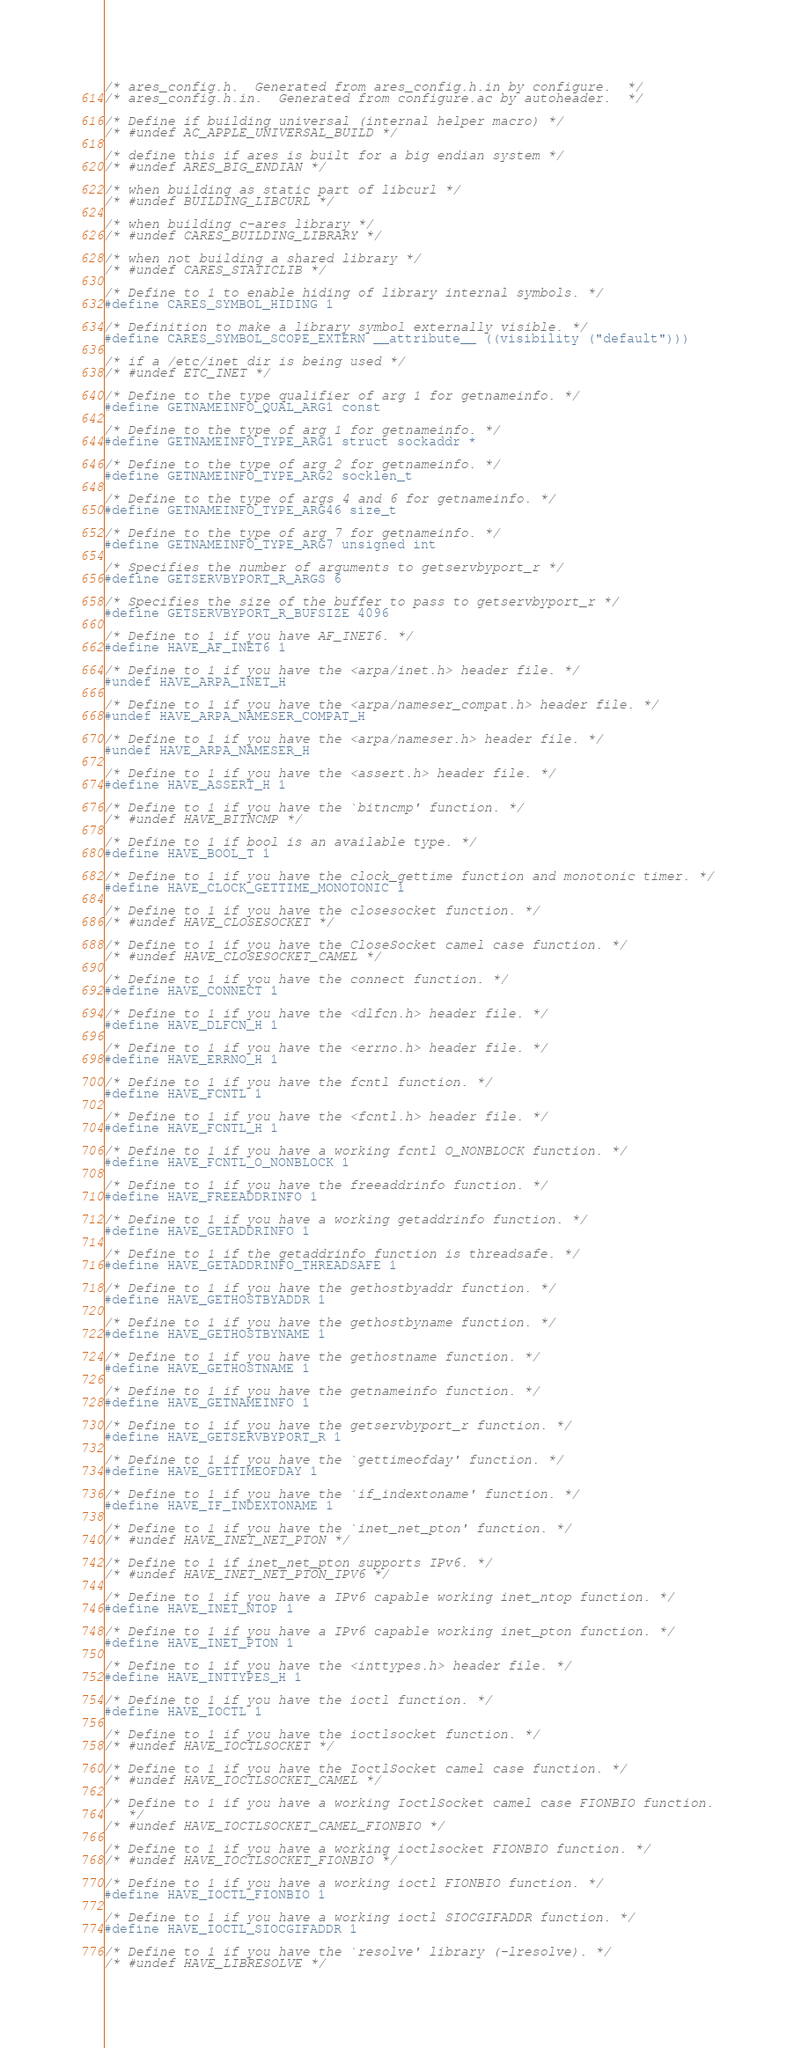<code> <loc_0><loc_0><loc_500><loc_500><_C_>/* ares_config.h.  Generated from ares_config.h.in by configure.  */
/* ares_config.h.in.  Generated from configure.ac by autoheader.  */

/* Define if building universal (internal helper macro) */
/* #undef AC_APPLE_UNIVERSAL_BUILD */

/* define this if ares is built for a big endian system */
/* #undef ARES_BIG_ENDIAN */

/* when building as static part of libcurl */
/* #undef BUILDING_LIBCURL */

/* when building c-ares library */
/* #undef CARES_BUILDING_LIBRARY */

/* when not building a shared library */
/* #undef CARES_STATICLIB */

/* Define to 1 to enable hiding of library internal symbols. */
#define CARES_SYMBOL_HIDING 1

/* Definition to make a library symbol externally visible. */
#define CARES_SYMBOL_SCOPE_EXTERN __attribute__ ((visibility ("default")))

/* if a /etc/inet dir is being used */
/* #undef ETC_INET */

/* Define to the type qualifier of arg 1 for getnameinfo. */
#define GETNAMEINFO_QUAL_ARG1 const

/* Define to the type of arg 1 for getnameinfo. */
#define GETNAMEINFO_TYPE_ARG1 struct sockaddr *

/* Define to the type of arg 2 for getnameinfo. */
#define GETNAMEINFO_TYPE_ARG2 socklen_t

/* Define to the type of args 4 and 6 for getnameinfo. */
#define GETNAMEINFO_TYPE_ARG46 size_t

/* Define to the type of arg 7 for getnameinfo. */
#define GETNAMEINFO_TYPE_ARG7 unsigned int

/* Specifies the number of arguments to getservbyport_r */
#define GETSERVBYPORT_R_ARGS 6

/* Specifies the size of the buffer to pass to getservbyport_r */
#define GETSERVBYPORT_R_BUFSIZE 4096

/* Define to 1 if you have AF_INET6. */
#define HAVE_AF_INET6 1

/* Define to 1 if you have the <arpa/inet.h> header file. */
#undef HAVE_ARPA_INET_H

/* Define to 1 if you have the <arpa/nameser_compat.h> header file. */
#undef HAVE_ARPA_NAMESER_COMPAT_H

/* Define to 1 if you have the <arpa/nameser.h> header file. */
#undef HAVE_ARPA_NAMESER_H

/* Define to 1 if you have the <assert.h> header file. */
#define HAVE_ASSERT_H 1

/* Define to 1 if you have the `bitncmp' function. */
/* #undef HAVE_BITNCMP */

/* Define to 1 if bool is an available type. */
#define HAVE_BOOL_T 1

/* Define to 1 if you have the clock_gettime function and monotonic timer. */
#define HAVE_CLOCK_GETTIME_MONOTONIC 1

/* Define to 1 if you have the closesocket function. */
/* #undef HAVE_CLOSESOCKET */

/* Define to 1 if you have the CloseSocket camel case function. */
/* #undef HAVE_CLOSESOCKET_CAMEL */

/* Define to 1 if you have the connect function. */
#define HAVE_CONNECT 1

/* Define to 1 if you have the <dlfcn.h> header file. */
#define HAVE_DLFCN_H 1

/* Define to 1 if you have the <errno.h> header file. */
#define HAVE_ERRNO_H 1

/* Define to 1 if you have the fcntl function. */
#define HAVE_FCNTL 1

/* Define to 1 if you have the <fcntl.h> header file. */
#define HAVE_FCNTL_H 1

/* Define to 1 if you have a working fcntl O_NONBLOCK function. */
#define HAVE_FCNTL_O_NONBLOCK 1

/* Define to 1 if you have the freeaddrinfo function. */
#define HAVE_FREEADDRINFO 1

/* Define to 1 if you have a working getaddrinfo function. */
#define HAVE_GETADDRINFO 1

/* Define to 1 if the getaddrinfo function is threadsafe. */
#define HAVE_GETADDRINFO_THREADSAFE 1

/* Define to 1 if you have the gethostbyaddr function. */
#define HAVE_GETHOSTBYADDR 1

/* Define to 1 if you have the gethostbyname function. */
#define HAVE_GETHOSTBYNAME 1

/* Define to 1 if you have the gethostname function. */
#define HAVE_GETHOSTNAME 1

/* Define to 1 if you have the getnameinfo function. */
#define HAVE_GETNAMEINFO 1

/* Define to 1 if you have the getservbyport_r function. */
#define HAVE_GETSERVBYPORT_R 1

/* Define to 1 if you have the `gettimeofday' function. */
#define HAVE_GETTIMEOFDAY 1

/* Define to 1 if you have the `if_indextoname' function. */
#define HAVE_IF_INDEXTONAME 1

/* Define to 1 if you have the `inet_net_pton' function. */
/* #undef HAVE_INET_NET_PTON */

/* Define to 1 if inet_net_pton supports IPv6. */
/* #undef HAVE_INET_NET_PTON_IPV6 */

/* Define to 1 if you have a IPv6 capable working inet_ntop function. */
#define HAVE_INET_NTOP 1

/* Define to 1 if you have a IPv6 capable working inet_pton function. */
#define HAVE_INET_PTON 1

/* Define to 1 if you have the <inttypes.h> header file. */
#define HAVE_INTTYPES_H 1

/* Define to 1 if you have the ioctl function. */
#define HAVE_IOCTL 1

/* Define to 1 if you have the ioctlsocket function. */
/* #undef HAVE_IOCTLSOCKET */

/* Define to 1 if you have the IoctlSocket camel case function. */
/* #undef HAVE_IOCTLSOCKET_CAMEL */

/* Define to 1 if you have a working IoctlSocket camel case FIONBIO function.
   */
/* #undef HAVE_IOCTLSOCKET_CAMEL_FIONBIO */

/* Define to 1 if you have a working ioctlsocket FIONBIO function. */
/* #undef HAVE_IOCTLSOCKET_FIONBIO */

/* Define to 1 if you have a working ioctl FIONBIO function. */
#define HAVE_IOCTL_FIONBIO 1

/* Define to 1 if you have a working ioctl SIOCGIFADDR function. */
#define HAVE_IOCTL_SIOCGIFADDR 1

/* Define to 1 if you have the `resolve' library (-lresolve). */
/* #undef HAVE_LIBRESOLVE */
</code> 